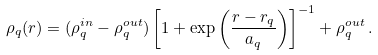Convert formula to latex. <formula><loc_0><loc_0><loc_500><loc_500>\rho _ { q } ( r ) = ( \rho _ { q } ^ { i n } - \rho _ { q } ^ { o u t } ) \left [ 1 + \exp \left ( \frac { r - r _ { q } } { a _ { q } } \right ) \right ] ^ { - 1 } + \rho _ { q } ^ { o u t } \, .</formula> 